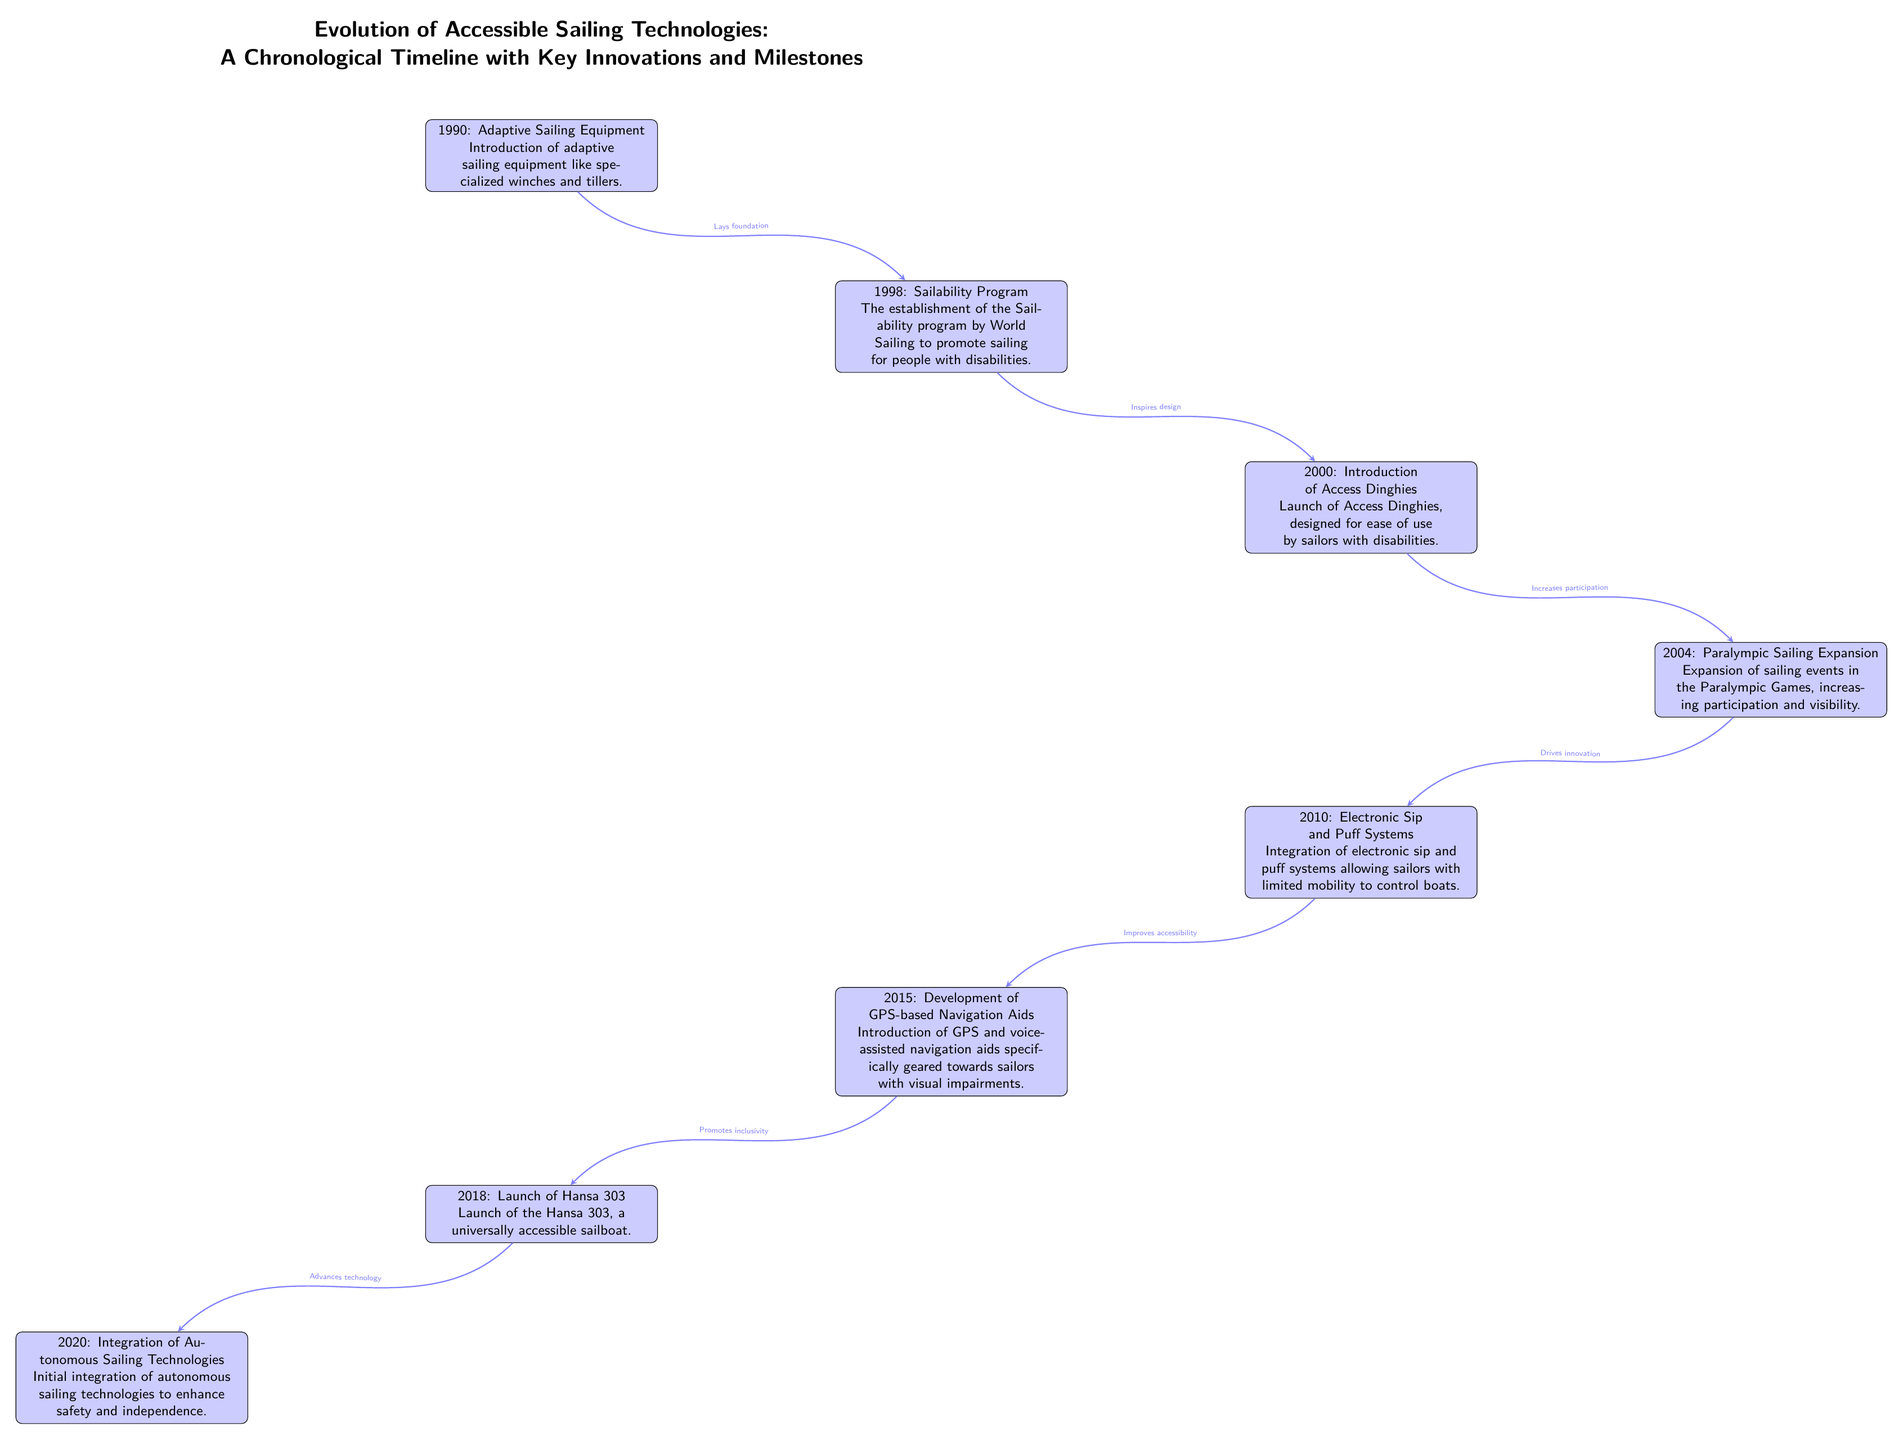What year did the Sailability program start? The Sailability program was established in 1998, as noted in the second node of the diagram.
Answer: 1998 What key innovation was introduced in 2000? The node for the year 2000 mentions the introduction of Access Dinghies, which are designed for ease of use by sailors with disabilities.
Answer: Access Dinghies How many main innovations are listed in the timeline? By counting the nodes in the diagram, we find there are eight key innovations listed from 1990 to 2020.
Answer: 8 Which milestone emphasizes the integration of electronic technologies for sailors with limited mobility? The node for 2010 discusses the introduction of electronic sip and puff systems that enables sailors with limited mobility to control boats.
Answer: Electronic sip and puff systems What is the relationship between the expansion of Paralympic sailing in 2004 and innovation in 2010? The diagram indicates that the expansion of sailing events in the Paralympic Games in 2004 drives innovation, which leads to the development of electronic sip and puff systems in 2010.
Answer: Drives innovation Which year marks the launch of the Hansa 303? Referring to the corresponding node, the Hansa 303 was launched in 2018 as a universally accessible sailboat.
Answer: 2018 What innovation was introduced in 2015 to assist sailors with visual impairments? The 2015 node points to the development of GPS-based navigation aids that are specifically geared towards sailors with visual impairments.
Answer: GPS-based navigation aids How do the innovations from 2000 to 2010 influence participation in sailing? According to the arrows in the diagram, the introduction of Access Dinghies increases participation, and then the later integration of electronic technologies improves accessibility, further encouraging participation among sailors with disabilities.
Answer: Increases participation What milestone represents a significant technological advancement in sailboat autonomy? The node for the year 2020 states that it involves the integration of autonomous sailing technologies, which represent an advancement in the technology of sailing.
Answer: Autonomous sailing technologies 